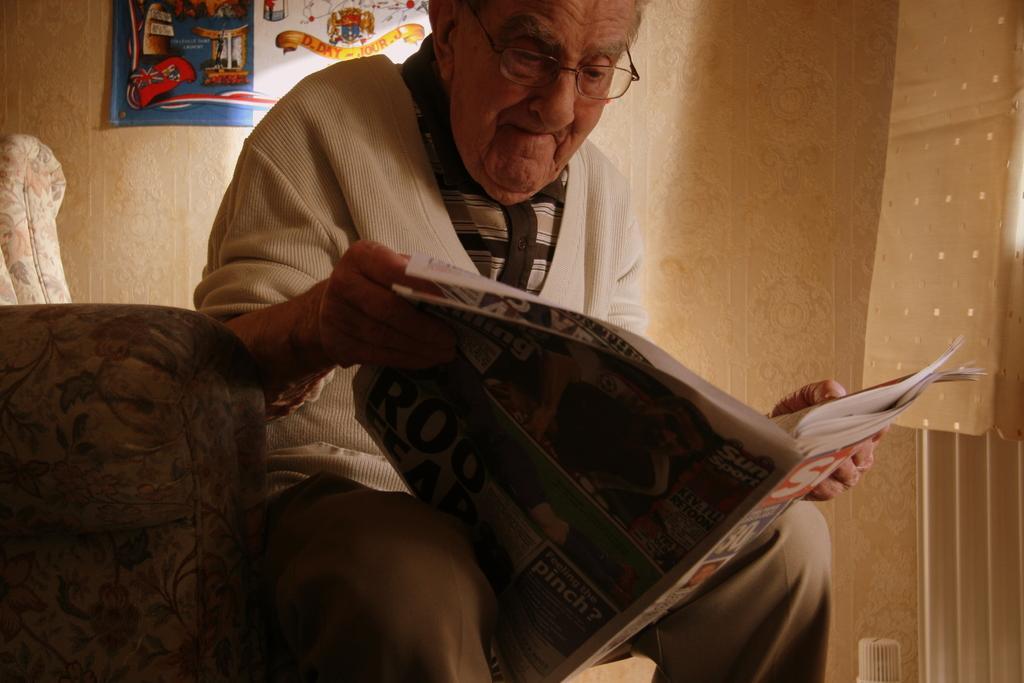How would you summarize this image in a sentence or two? In this image we can see a man sitting on the couch and holding a news paper in his hands. In the background we can see walls and an advertisement. 